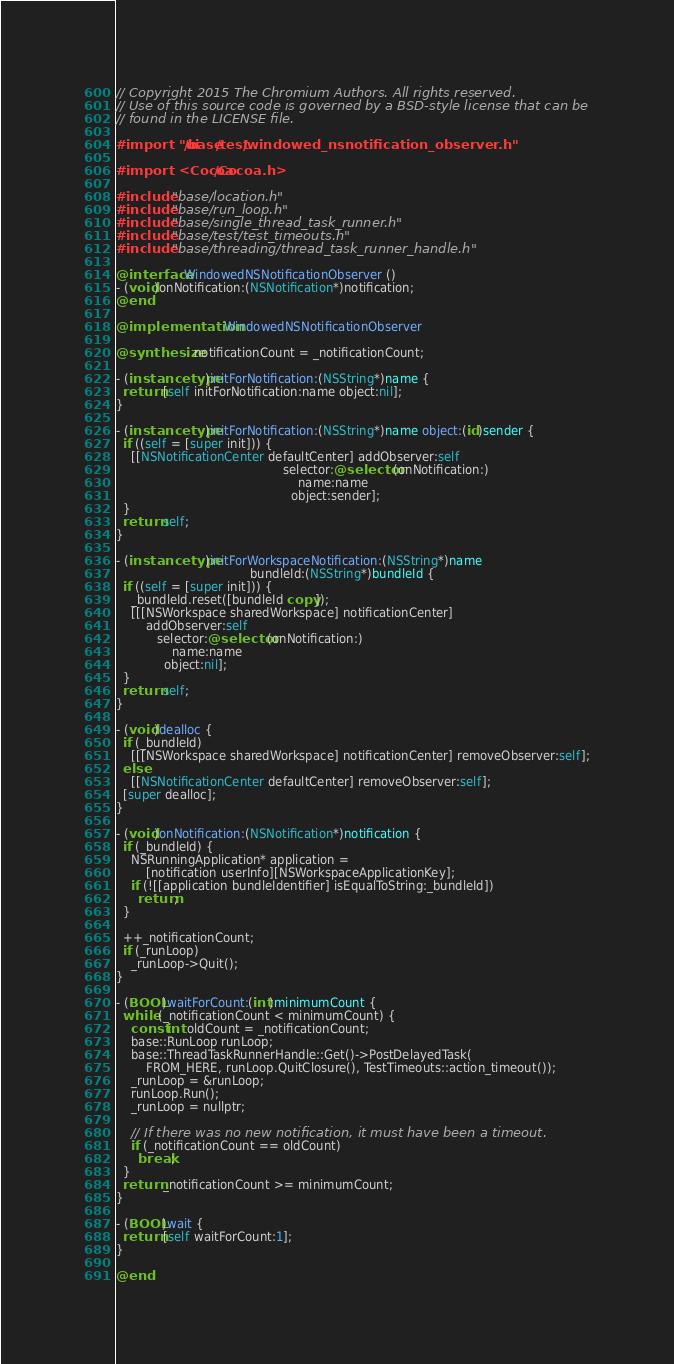<code> <loc_0><loc_0><loc_500><loc_500><_ObjectiveC_>// Copyright 2015 The Chromium Authors. All rights reserved.
// Use of this source code is governed by a BSD-style license that can be
// found in the LICENSE file.

#import "ui/base/test/windowed_nsnotification_observer.h"

#import <Cocoa/Cocoa.h>

#include "base/location.h"
#include "base/run_loop.h"
#include "base/single_thread_task_runner.h"
#include "base/test/test_timeouts.h"
#include "base/threading/thread_task_runner_handle.h"

@interface WindowedNSNotificationObserver ()
- (void)onNotification:(NSNotification*)notification;
@end

@implementation WindowedNSNotificationObserver

@synthesize notificationCount = _notificationCount;

- (instancetype)initForNotification:(NSString*)name {
  return [self initForNotification:name object:nil];
}

- (instancetype)initForNotification:(NSString*)name object:(id)sender {
  if ((self = [super init])) {
    [[NSNotificationCenter defaultCenter] addObserver:self
                                             selector:@selector(onNotification:)
                                                 name:name
                                               object:sender];
  }
  return self;
}

- (instancetype)initForWorkspaceNotification:(NSString*)name
                                    bundleId:(NSString*)bundleId {
  if ((self = [super init])) {
    _bundleId.reset([bundleId copy]);
    [[[NSWorkspace sharedWorkspace] notificationCenter]
        addObserver:self
           selector:@selector(onNotification:)
               name:name
             object:nil];
  }
  return self;
}

- (void)dealloc {
  if (_bundleId)
    [[[NSWorkspace sharedWorkspace] notificationCenter] removeObserver:self];
  else
    [[NSNotificationCenter defaultCenter] removeObserver:self];
  [super dealloc];
}

- (void)onNotification:(NSNotification*)notification {
  if (_bundleId) {
    NSRunningApplication* application =
        [notification userInfo][NSWorkspaceApplicationKey];
    if (![[application bundleIdentifier] isEqualToString:_bundleId])
      return;
  }

  ++_notificationCount;
  if (_runLoop)
    _runLoop->Quit();
}

- (BOOL)waitForCount:(int)minimumCount {
  while (_notificationCount < minimumCount) {
    const int oldCount = _notificationCount;
    base::RunLoop runLoop;
    base::ThreadTaskRunnerHandle::Get()->PostDelayedTask(
        FROM_HERE, runLoop.QuitClosure(), TestTimeouts::action_timeout());
    _runLoop = &runLoop;
    runLoop.Run();
    _runLoop = nullptr;

    // If there was no new notification, it must have been a timeout.
    if (_notificationCount == oldCount)
      break;
  }
  return _notificationCount >= minimumCount;
}

- (BOOL)wait {
  return [self waitForCount:1];
}

@end
</code> 